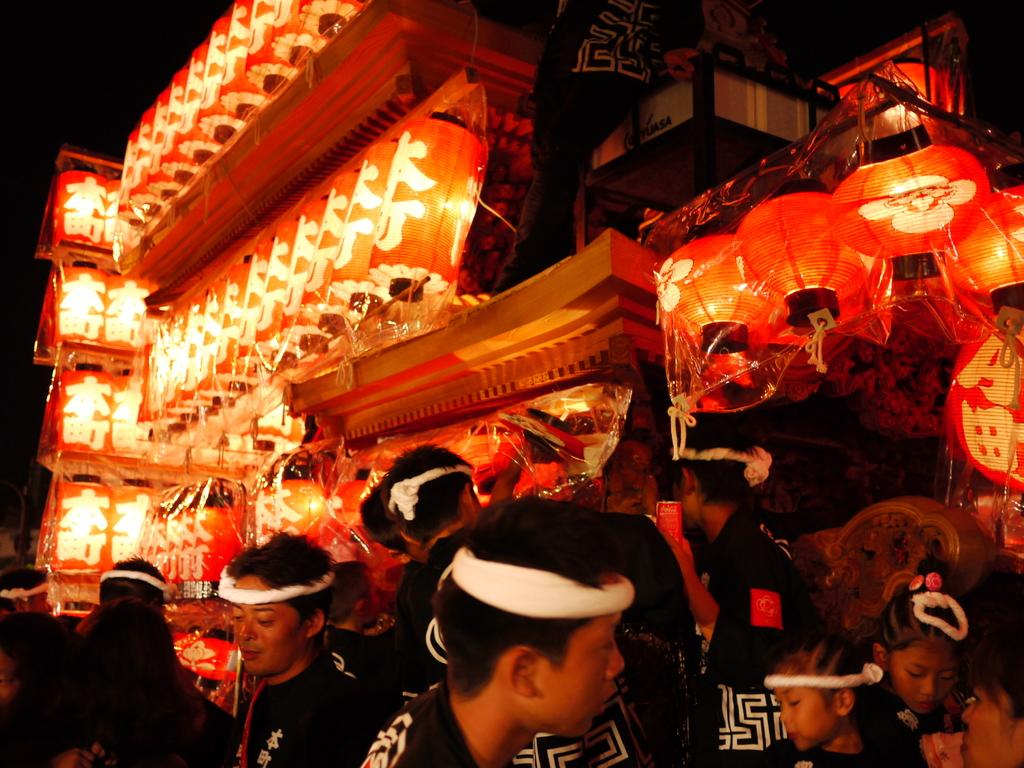Who or what is present in the image? There are people in the image. What type of lighting is visible in the image? There are lamps in the image. Can you describe any other objects present in the image? There are other objects in the image, but their specific details are not mentioned in the provided facts. What type of bone is being used as a musical instrument in the image? There is no bone present in the image, let alone one being used as a musical instrument. 